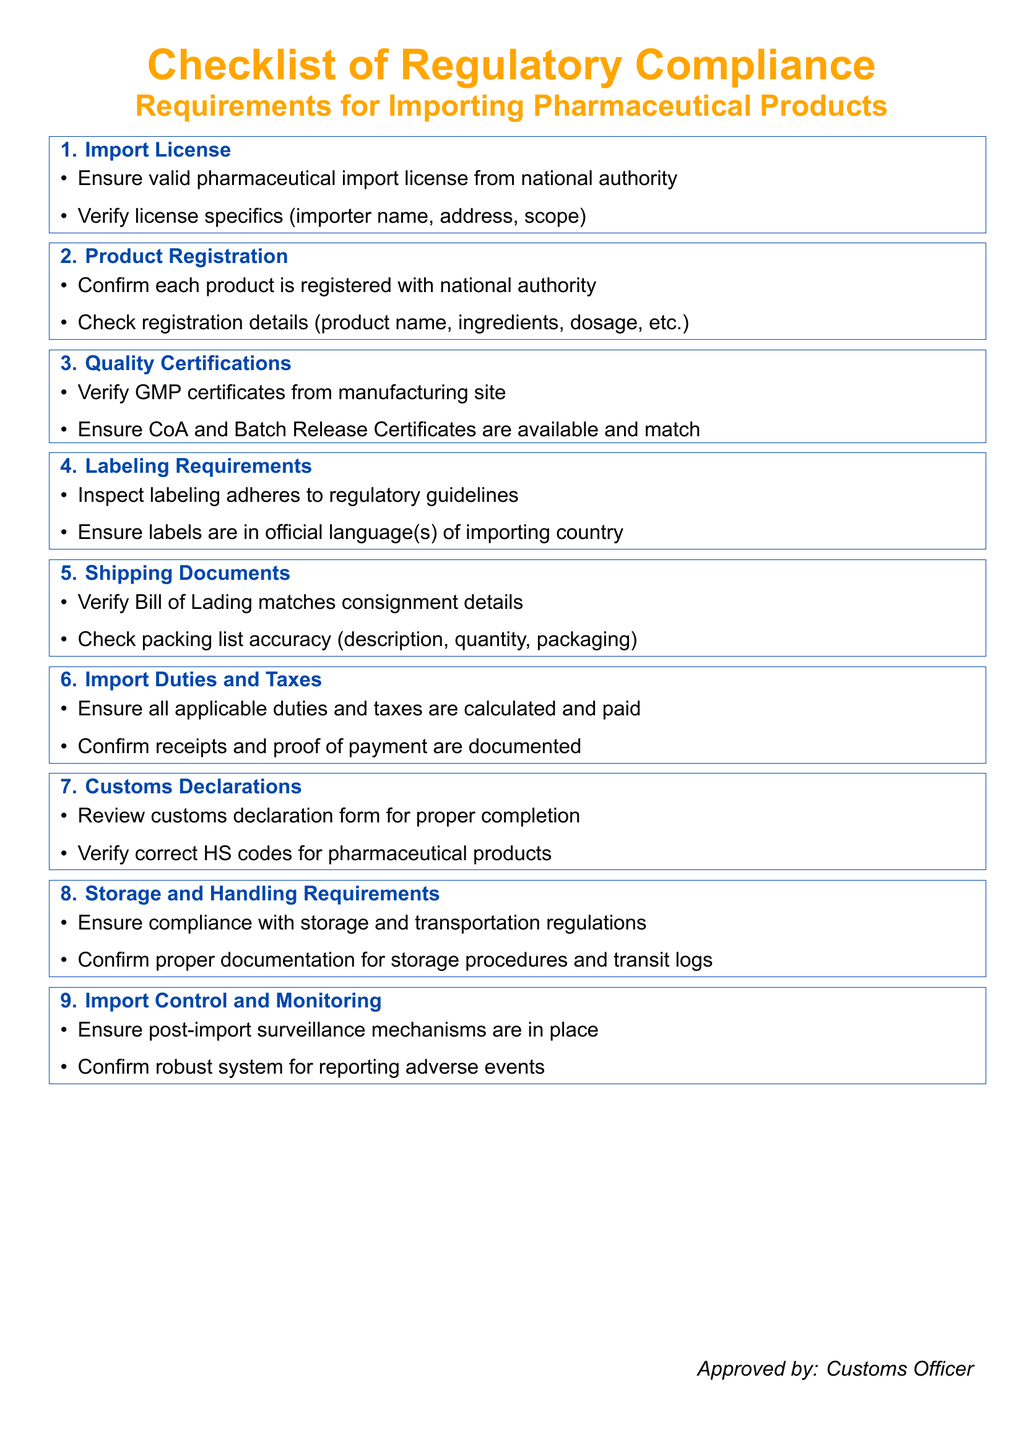What is the title of the document? The title of the document is clearly stated at the top, mentioning it is a checklist for regulatory compliance for importing pharmaceutical products.
Answer: Checklist of Regulatory Compliance Requirements for Importing Pharmaceutical Products How many main sections are in the checklist? The number of main sections in the checklist can be counted from the ticket boxes listed in the document.
Answer: 9 What is the first requirement listed? The first requirement in the checklist is represented in the first ticket box for import licenses.
Answer: Import License What must be checked in shipping documents? The shipping documents section specifies to verify the Bill of Lading and check the packing list accuracy.
Answer: Bill of Lading matches consignment details What is required for quality certifications? The quality certifications section includes verification of GMP certificates and ensuring CoA and Batch Release Certificates are available.
Answer: GMP certificates from manufacturing site What type of documentation is required for import duties and taxes? In the checklist, it is specified that receipts and proof of payment for duties and taxes need to be documented.
Answer: Receipts and proof of payment What does the import control and monitoring section specifically require? This section emphasizes the need for post-import surveillance mechanisms and a robust system for reporting adverse events.
Answer: Post-import surveillance mechanisms In which language(s) should labels be? The labeling requirements specify that labels must be in the official language(s) of the importing country.
Answer: Official language(s) of importing country What is the last section title in the checklist? The last section of the checklist can be identified by looking at the final ticket box.
Answer: Import Control and Monitoring 